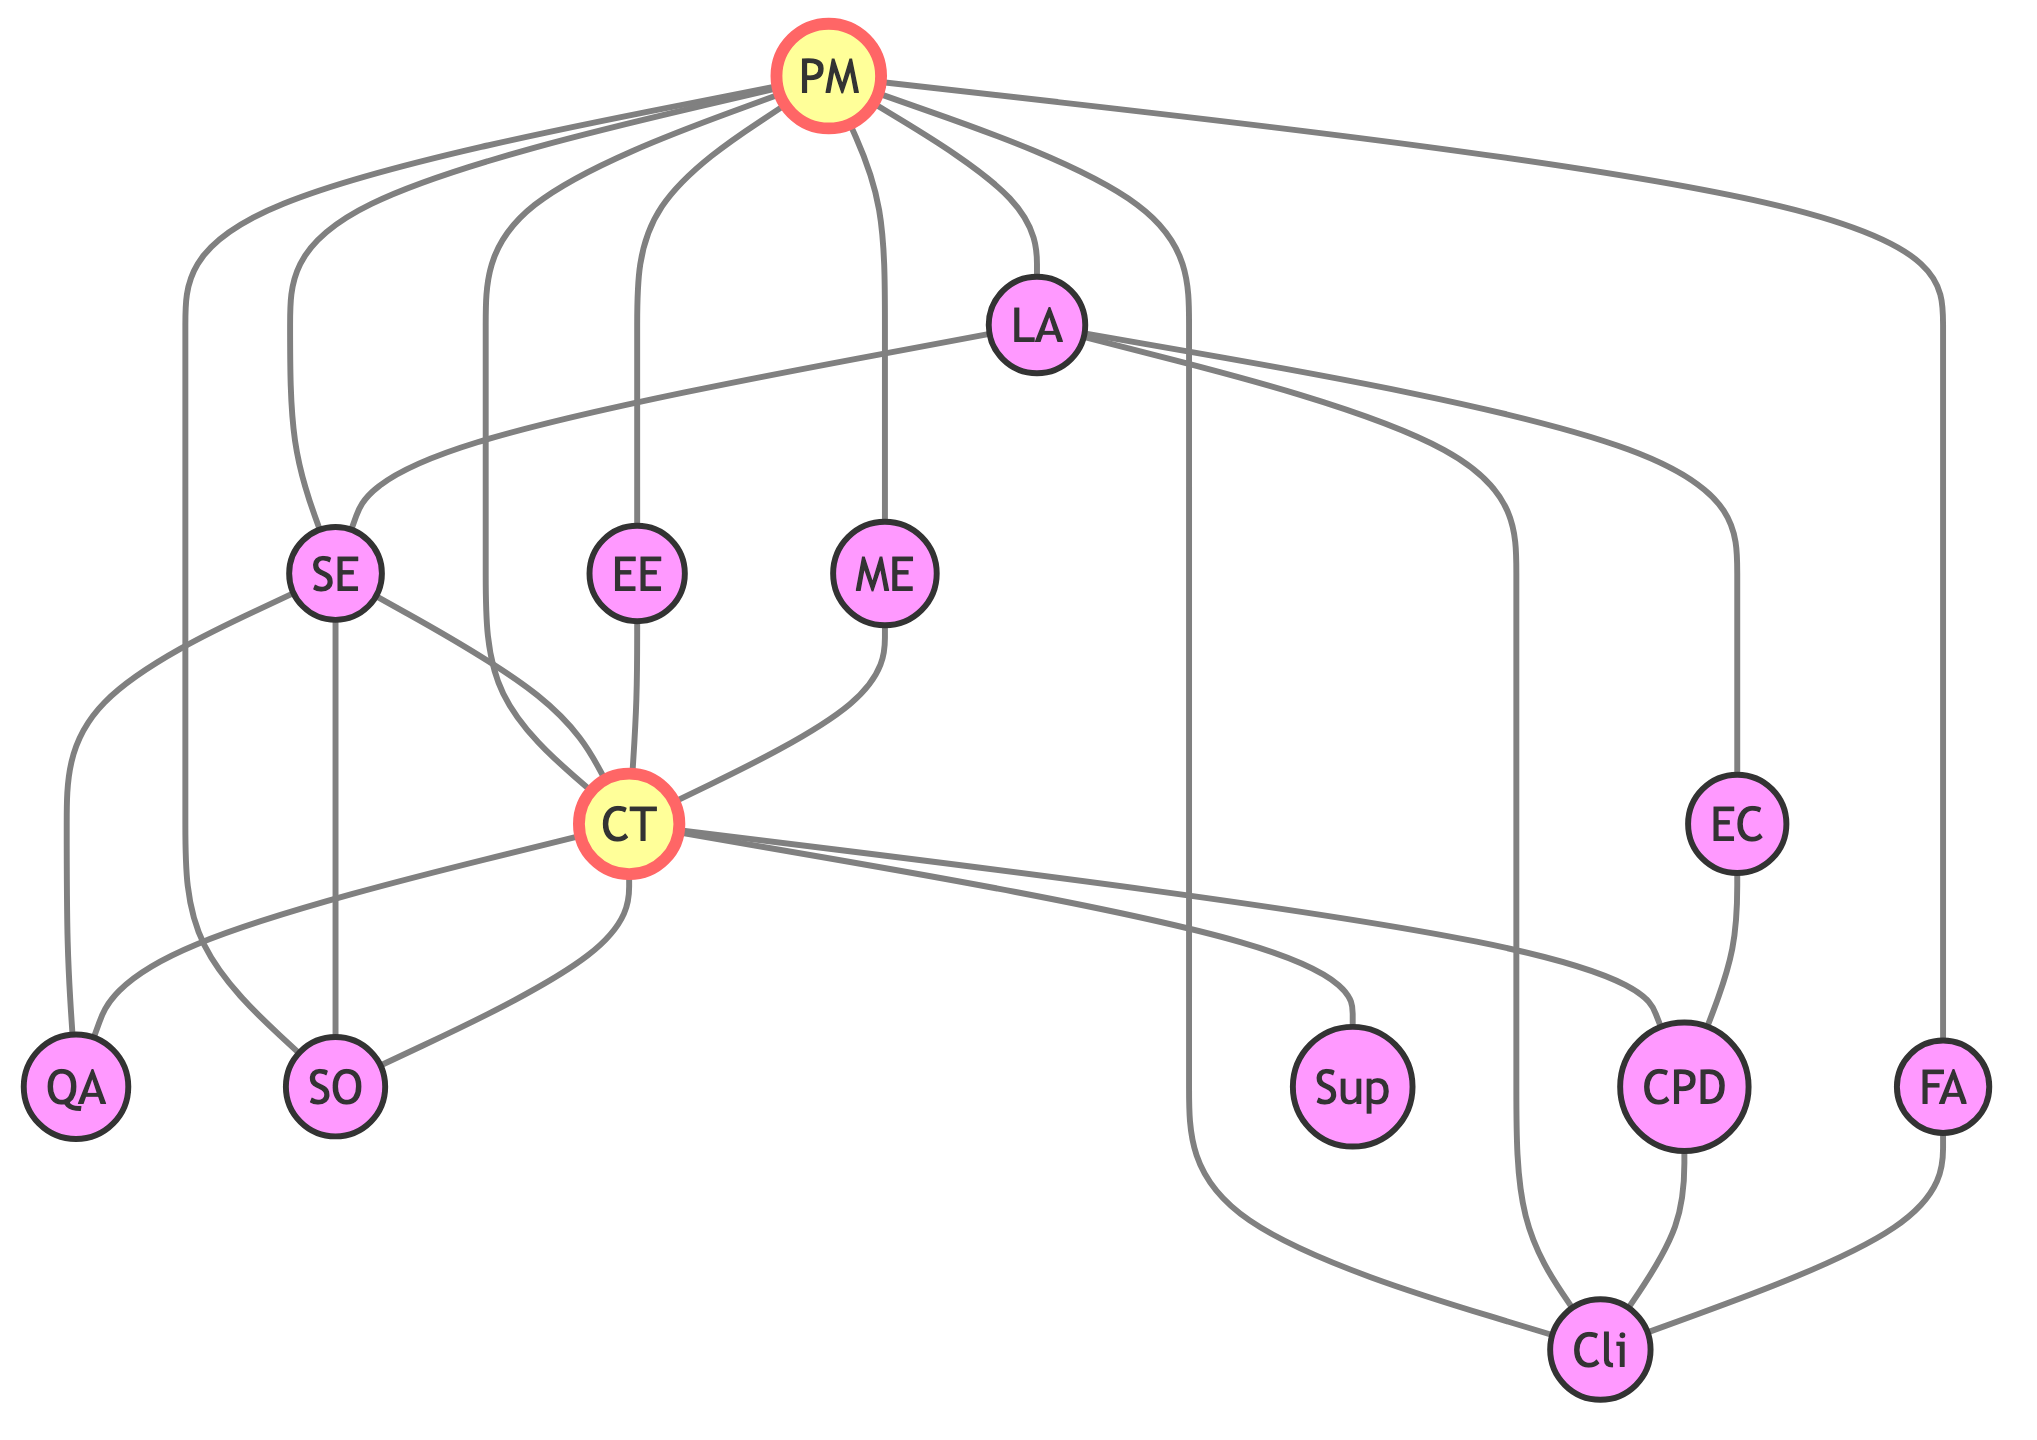What is the total number of nodes in the graph? By counting each labeled entity in the nodes section of the provided data, we find there are 13 unique entities, which are the key teams and stakeholders involved in the construction project.
Answer: 13 How many edges connect to the Project Manager? The Project Manager (node 1) is connected to 8 edges, which can be counted from the edges list where node 1 is the source. These connections involve various teams and stakeholders essential for project coordination.
Answer: 8 Which team is directly connected to the Structural Engineer? Looking at the edges connected to the Structural Engineer (node 3), we see that it is directly connected to the Construction Team (node 6), Quality Assurance Team (node 7), and Safety Officer (node 8). Therefore, the most relevant direct connection is the Construction Team.
Answer: Construction Team How many total connections does the Construction Team have? The Construction Team (node 6) is connected to 6 different nodes: Project Manager (node 1), Structural Engineer (node 3), Quality Assurance Team (node 7), Safety Officer (node 8), Suppliers (node 10), and City Planning Department (node 9). Thus, it has a total of 6 connections.
Answer: 6 Which stakeholder is connected to both the Clients and the City Planning Department? Reviewing the edges, the City Planning Department (node 9) connects to the Clients (node 11), which, in turn, is also connected to the Financial Advisor (node 13). The stakeholder that connects both is the City Planning Department.
Answer: City Planning Department Are the Electrical Engineer and Mechanical Engineer directly connected to each other? Checking the edges, there are no direct connections listed between the Electrical Engineer (node 4) and the Mechanical Engineer (node 5). Therefore, they are not directly connected.
Answer: No What is the primary role of the node labeled 'QA'? The 'QA' node corresponds to the Quality Assurance Team, which ensures that the construction meets the required standards and specifications critical for the project's success.
Answer: Quality Assurance Team How many nodes are connected to the Safety Officer? The Safety Officer (node 8) is connected to 3 nodes: Project Manager (node 1), Structural Engineer (node 3), and Construction Team (node 6). Thus, there are 3 connections to the Safety Officer.
Answer: 3 Which node has the most connections within the graph? The Project Manager (node 1) has connections to 8 different nodes, making it the most connected entity in the graph compared to other nodes.
Answer: Project Manager 